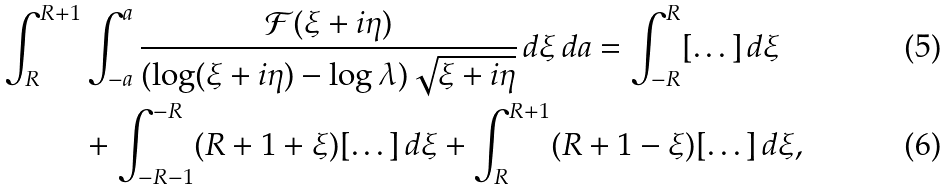<formula> <loc_0><loc_0><loc_500><loc_500>\int _ { R } ^ { R + 1 } & \int _ { - a } ^ { a } \frac { \mathcal { F } ( \xi + i \eta ) } { ( \log ( \xi + i \eta ) - \log \lambda ) \sqrt { \xi + i \eta } } \, d \xi \, d a = \int _ { - R } ^ { R } [ \dots ] \, d \xi \\ & + \int _ { - R - 1 } ^ { - R } ( R + 1 + \xi ) [ \dots ] \, d \xi + \int _ { R } ^ { R + 1 } ( R + 1 - \xi ) [ \dots ] \, d \xi ,</formula> 